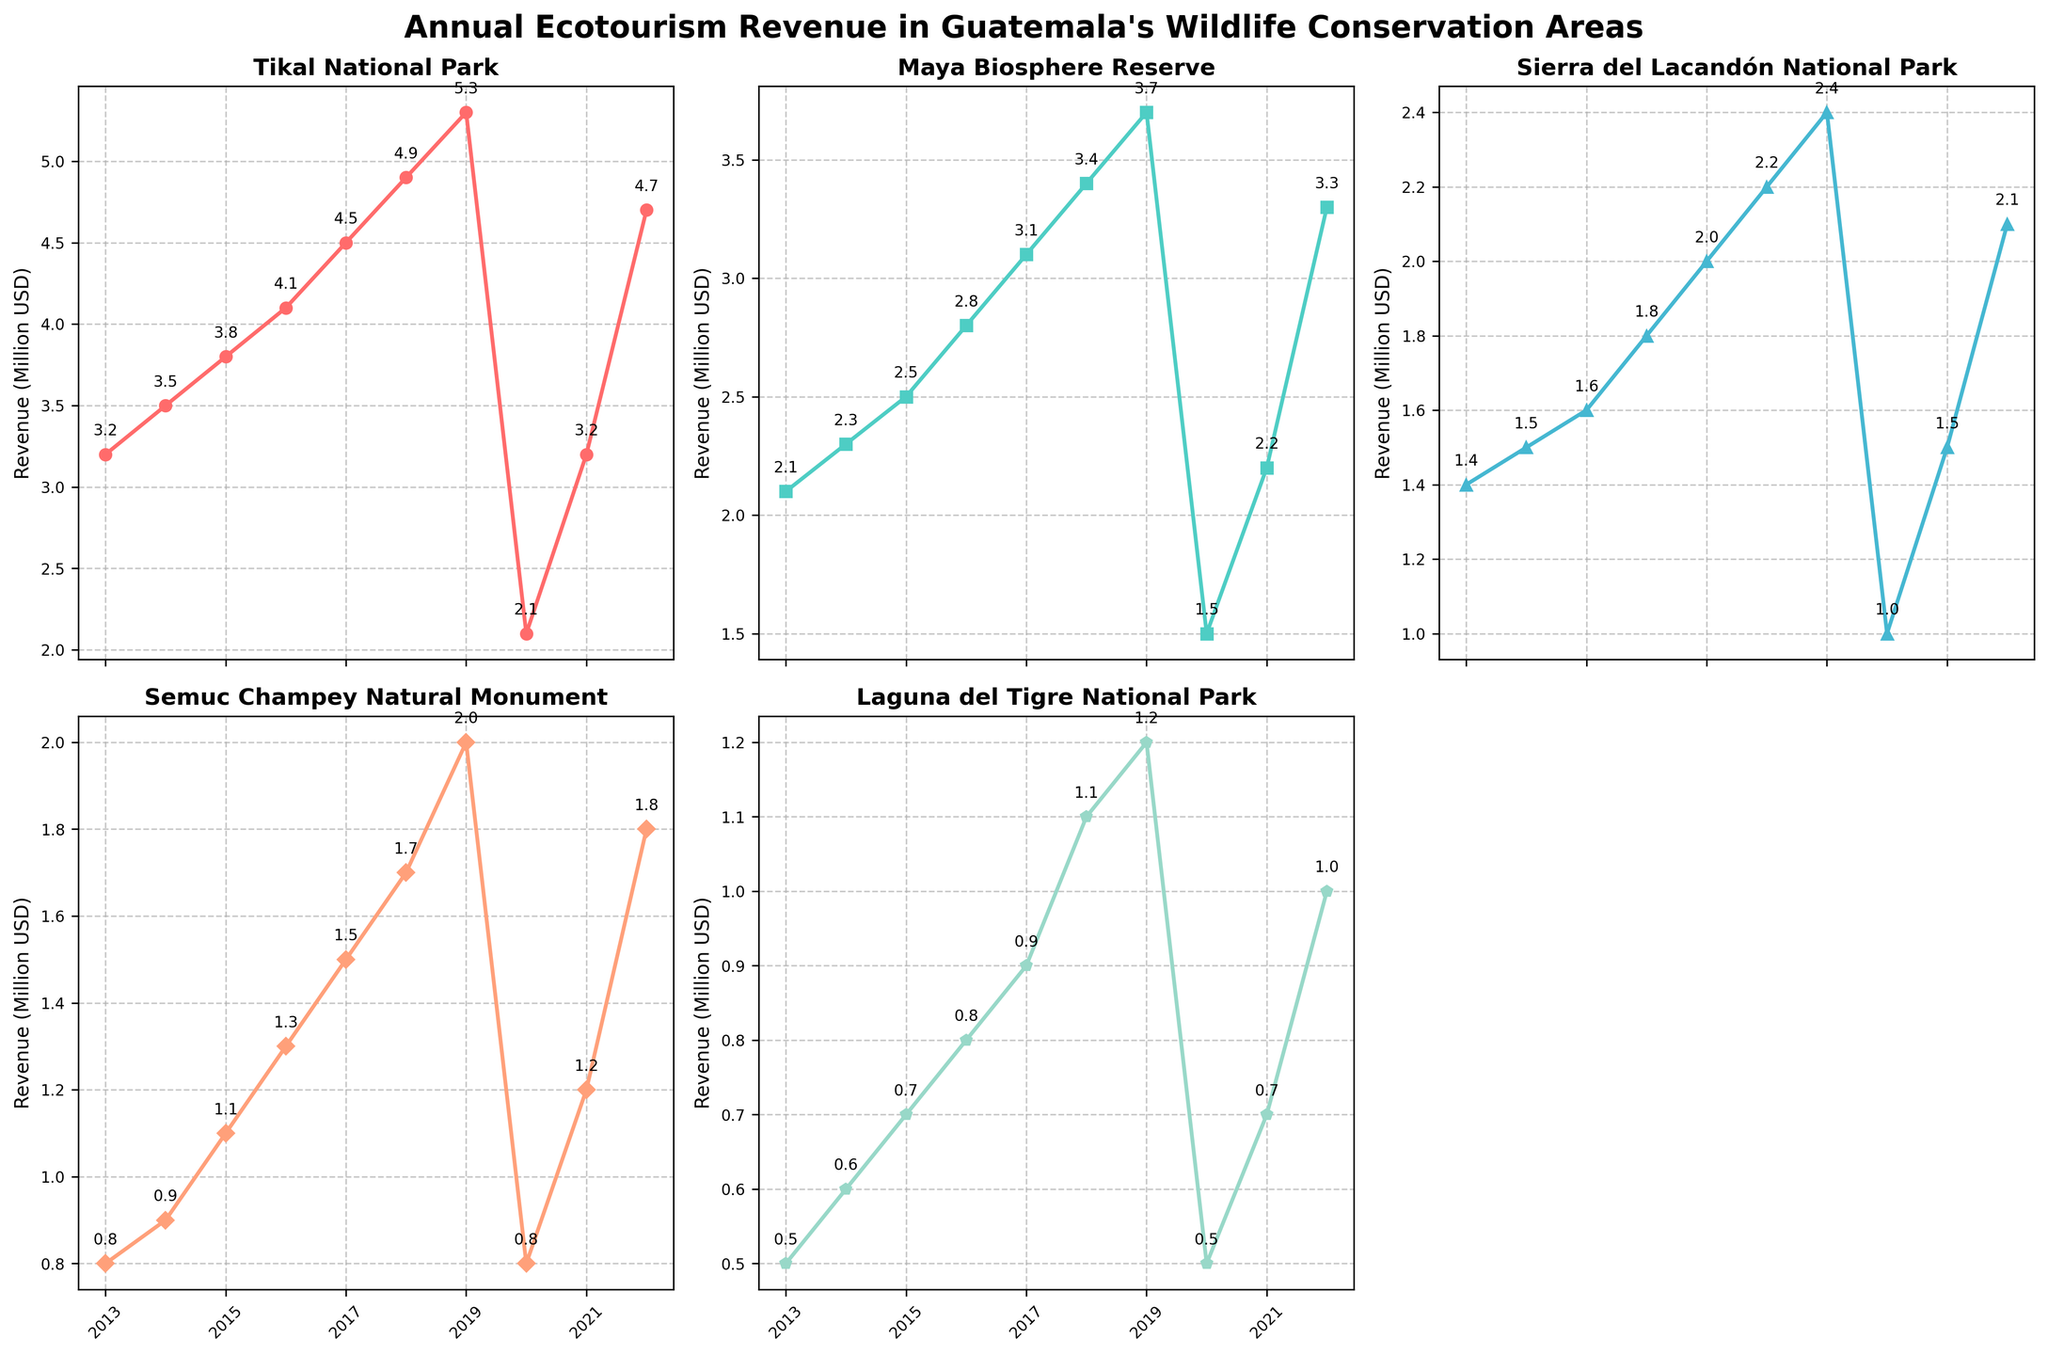What is the title of the figure? The title of the figure is located at the top center and summarizes the overall purpose of the figure.
Answer: Annual Ecotourism Revenue in Guatemala's Wildlife Conservation Areas How many wildlife conservation areas are included in the figure? There are six subplots, but one is empty. Each occupied subplot represents data for a different wildlife conservation area.
Answer: Five What year saw the lowest revenue for Tikal National Park? By tracing the line in Tikal National Park's subplot, the lowest point is in 2020.
Answer: 2020 Which conservation area had the highest revenue in 2022? Check the final data point of 2022 for each subplot and compare their values. The highest revenue is in Tikal National Park.
Answer: Tikal National Park In which year did Semuc Champey Natural Monument see a sharp rise in revenue? A sharp rise is indicated by a steep slope in Semuc Champey's subplot. This occurs between 2019 and 2022.
Answer: 2019-2020 Which conservation area experienced the smallest change in revenue over the decade? By visually comparing the slope of the lines in each subplot, the flattest line indicates the smallest change. Laguna del Tigre National Park shows the smallest change.
Answer: Laguna del Tigre National Park What is the combined revenue of all conservation areas in 2015? Find the revenue values for each area in 2015 and sum them up: Tikal (3.8), Maya Biosphere (2.5), Sierra del Lacandón (1.6), Semuc Champey (1.1), Laguna del Tigre (0.7). So, 3.8+2.5+1.6+1.1+0.7 = 9.7.
Answer: 9.7 million USD Which year shows a drop in revenue for all conservation areas? Identify the year with a downward slope in all subplots, 2020 shows a drop for every area.
Answer: 2020 What is the average revenue of Maya Biosphere Reserve over the decade? Sum the revenues for each year from 2013 to 2022 and divide by the number of years (10). So, (2.1+2.3+2.5+2.8+3.1+3.4+3.7+1.5+2.2+3.3) / 10 = 2.69 million USD.
Answer: 2.69 million USD Compare the revenue of Sierra del Lacandón National Park in 2013 and 2022 and state the difference. Find the values for Sierra del Lacandón in 2013 and 2022 and calculate the difference. In 2013, the revenue is 1.4; in 2022, it is 2.1. The difference is 2.1 - 1.4 = 0.7.
Answer: 0.7 million USD 